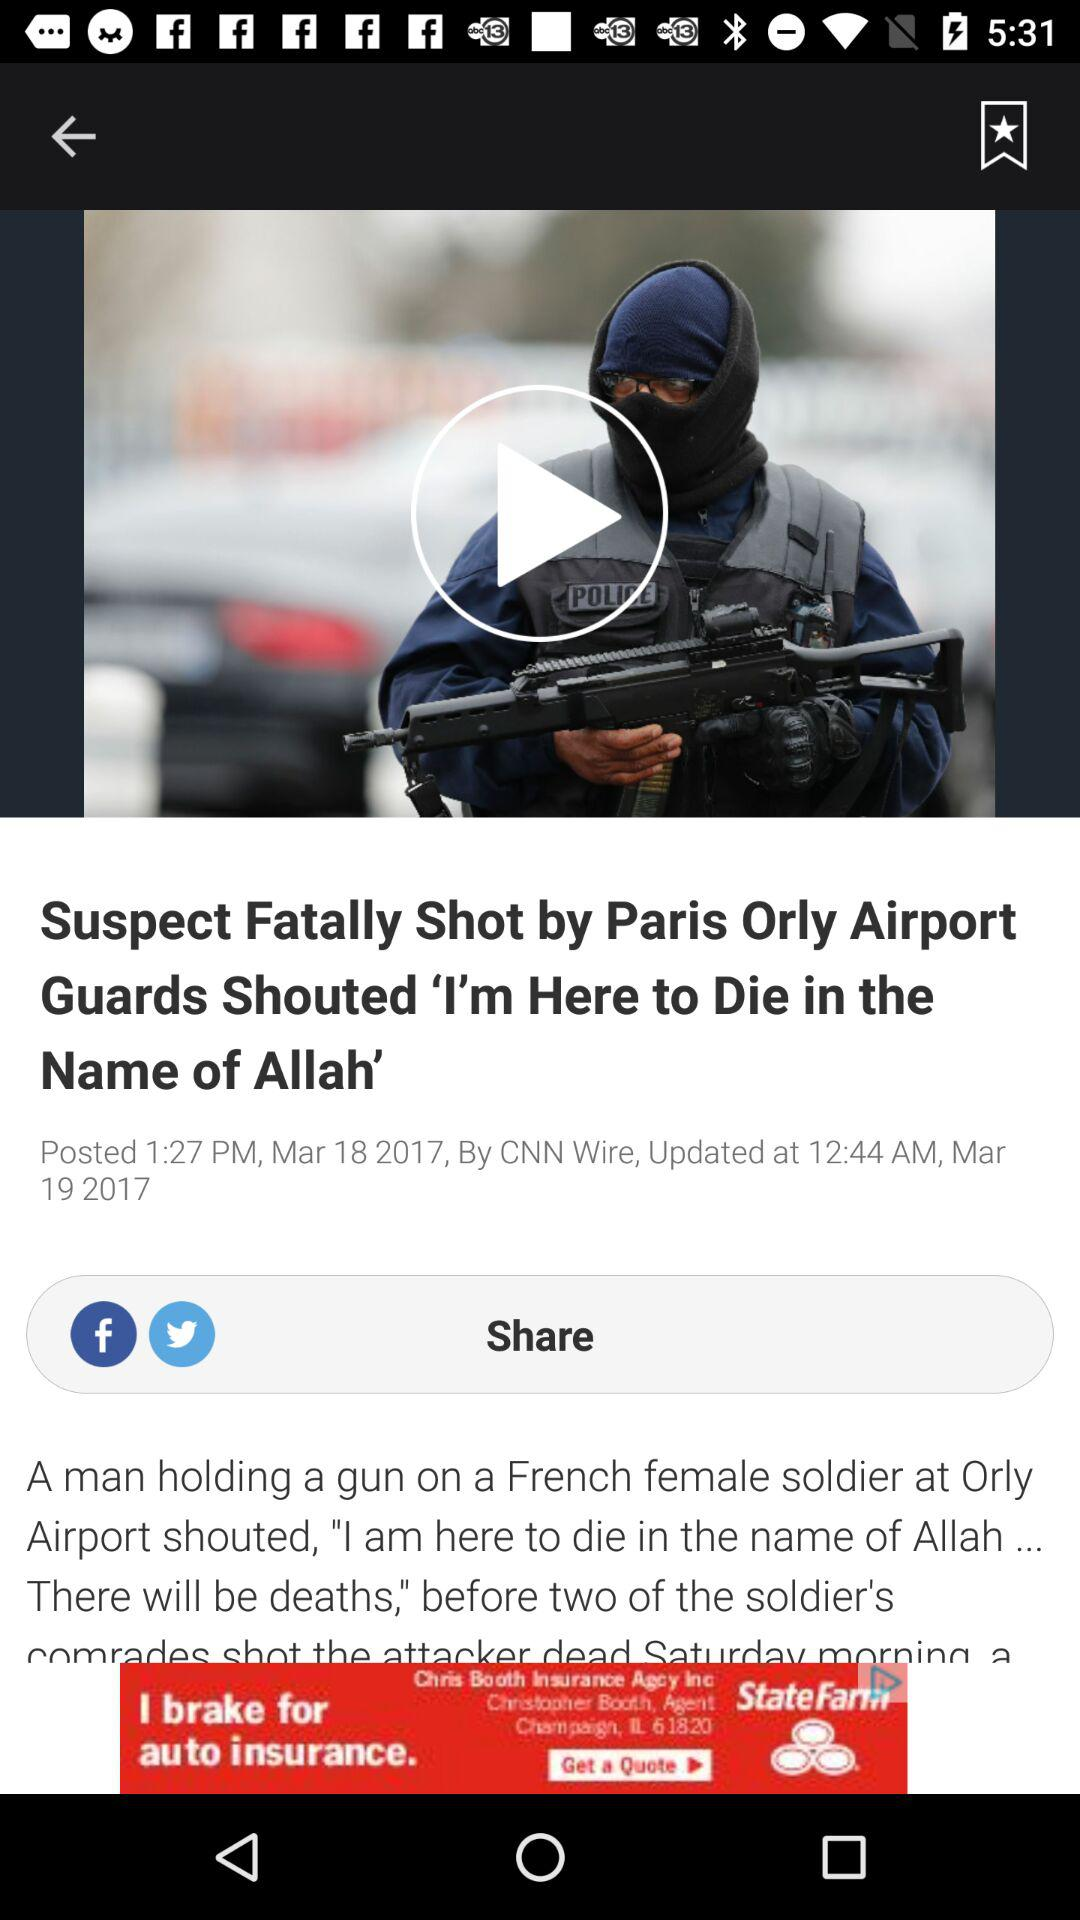What is the updated date of the article? The updated date is March 19, 2017. 